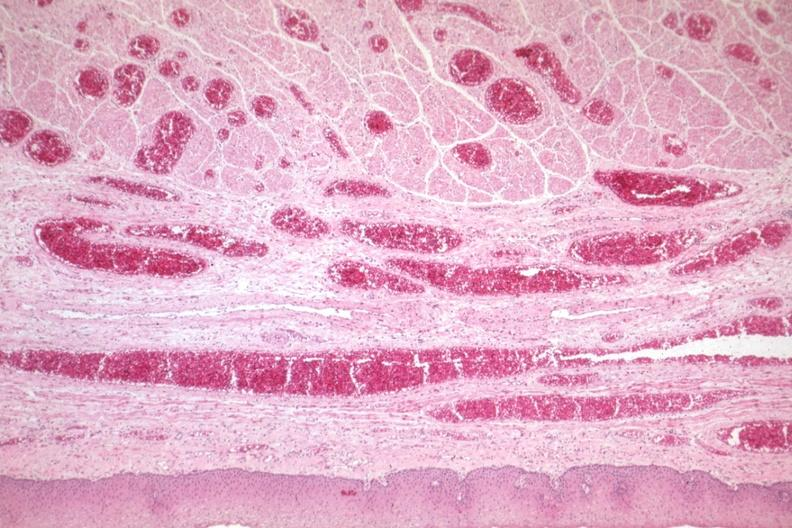s polycystic disease present?
Answer the question using a single word or phrase. No 